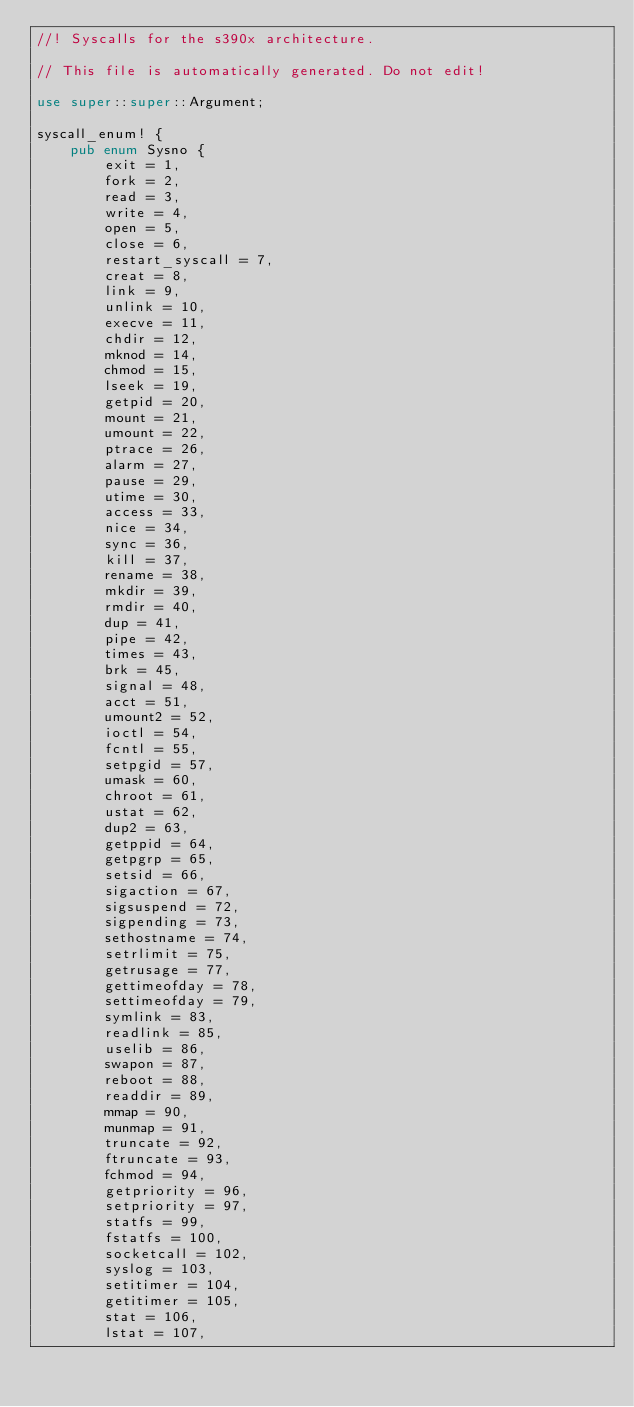<code> <loc_0><loc_0><loc_500><loc_500><_Rust_>//! Syscalls for the s390x architecture.

// This file is automatically generated. Do not edit!

use super::super::Argument;

syscall_enum! {
    pub enum Sysno {
        exit = 1,
        fork = 2,
        read = 3,
        write = 4,
        open = 5,
        close = 6,
        restart_syscall = 7,
        creat = 8,
        link = 9,
        unlink = 10,
        execve = 11,
        chdir = 12,
        mknod = 14,
        chmod = 15,
        lseek = 19,
        getpid = 20,
        mount = 21,
        umount = 22,
        ptrace = 26,
        alarm = 27,
        pause = 29,
        utime = 30,
        access = 33,
        nice = 34,
        sync = 36,
        kill = 37,
        rename = 38,
        mkdir = 39,
        rmdir = 40,
        dup = 41,
        pipe = 42,
        times = 43,
        brk = 45,
        signal = 48,
        acct = 51,
        umount2 = 52,
        ioctl = 54,
        fcntl = 55,
        setpgid = 57,
        umask = 60,
        chroot = 61,
        ustat = 62,
        dup2 = 63,
        getppid = 64,
        getpgrp = 65,
        setsid = 66,
        sigaction = 67,
        sigsuspend = 72,
        sigpending = 73,
        sethostname = 74,
        setrlimit = 75,
        getrusage = 77,
        gettimeofday = 78,
        settimeofday = 79,
        symlink = 83,
        readlink = 85,
        uselib = 86,
        swapon = 87,
        reboot = 88,
        readdir = 89,
        mmap = 90,
        munmap = 91,
        truncate = 92,
        ftruncate = 93,
        fchmod = 94,
        getpriority = 96,
        setpriority = 97,
        statfs = 99,
        fstatfs = 100,
        socketcall = 102,
        syslog = 103,
        setitimer = 104,
        getitimer = 105,
        stat = 106,
        lstat = 107,</code> 